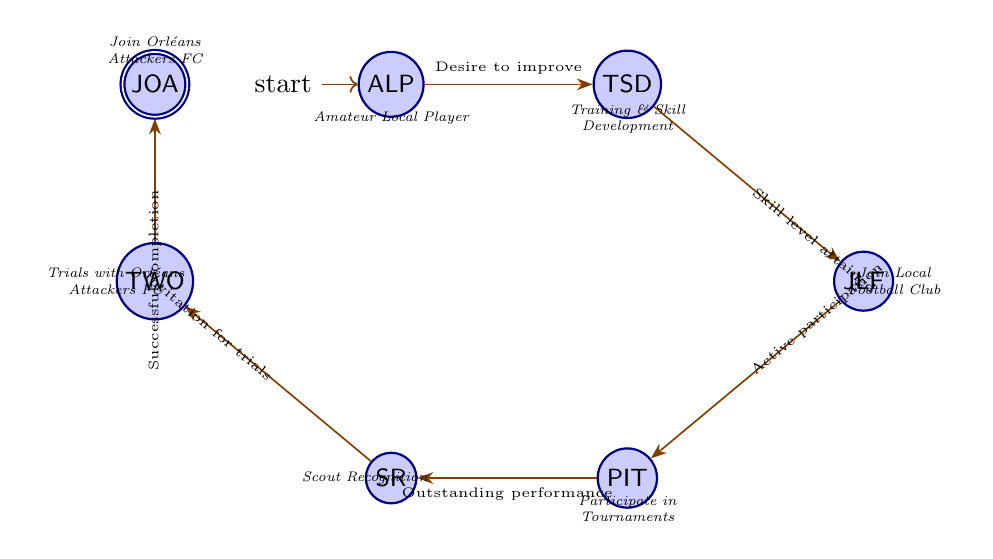What's the total number of states in the diagram? The diagram lists seven distinct states, which are Amateur Local Player, Training and Skill Development, Join Local Football Club, Participate in Tournaments, Scout Recognition, Trials with Orléans Attackers FC, and Join Orléans Attackers FC. Counting each one gives the total of seven states.
Answer: 7 What is the last state in the sequence? The diagram shows that the final state is labeled "Join Orléans Attackers FC." This is the destination state that an amateur local player aspires to reach.
Answer: Join Orléans Attackers FC What transition leads to "Trials with Orléans Attackers FC"? The transition that leads to "Trials with Orléans Attackers FC" comes from the state "Scout Recognition," and the condition for this transition is receiving an invitation from the scouts.
Answer: Invitation for trials Which state requires outstanding performance to advance? The state that requires outstanding performance to advance to the next phase is "Participate in Tournaments." This performance is a requirement for gaining recognition from scouts.
Answer: Participate in Tournaments How many transitions are there in the diagram? The diagram presents six transitions between the seven states, indicating the flow from one state to another based on specific conditions.
Answer: 6 What state follows "Join Local Football Club"? The state that directly follows "Join Local Football Club" in the progression is "Participate in Tournaments." The flow indicates that joining a club allows for tournament participation.
Answer: Participate in Tournaments Which state represents the starting point in the progression? The initial state of the progression, where the aspiring player begins their journey, is "Amateur Local Player." This is the entry point into the finite state machine.
Answer: Amateur Local Player Which condition must be met to transition from "Training and Skill Development" to "Join Local Football Club"? To transition from "Training and Skill Development" to "Join Local Football Club," the required condition is having attained a certain skill level and readiness. This ensures the player is prepared for club-level competition.
Answer: Skill level attained 